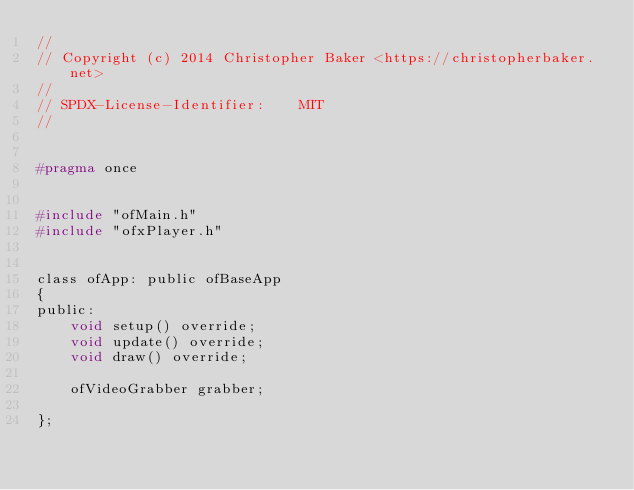Convert code to text. <code><loc_0><loc_0><loc_500><loc_500><_C_>//
// Copyright (c) 2014 Christopher Baker <https://christopherbaker.net>
//
// SPDX-License-Identifier:    MIT
//


#pragma once


#include "ofMain.h"
#include "ofxPlayer.h"


class ofApp: public ofBaseApp
{
public:
    void setup() override;
    void update() override;
    void draw() override;

    ofVideoGrabber grabber;

};
</code> 